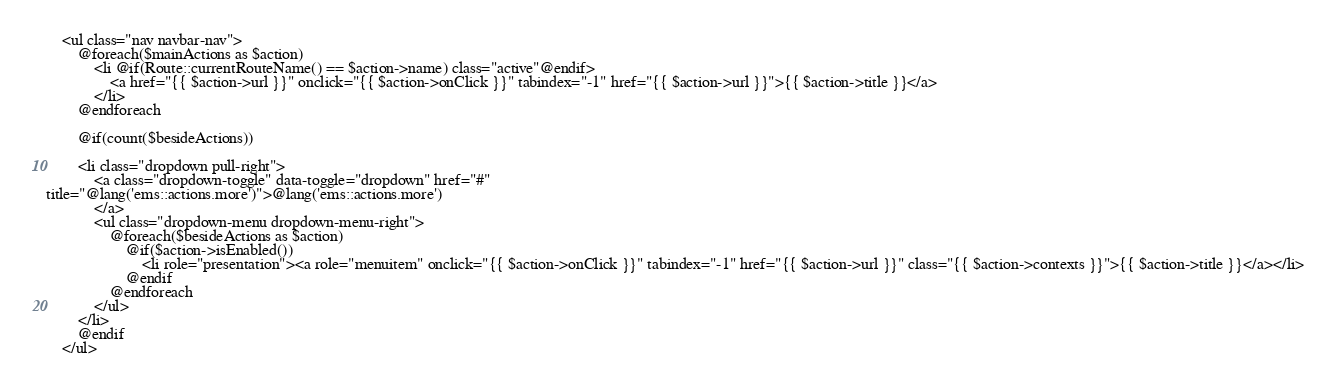Convert code to text. <code><loc_0><loc_0><loc_500><loc_500><_PHP_>    <ul class="nav navbar-nav">
        @foreach($mainActions as $action)
            <li @if(Route::currentRouteName() == $action->name) class="active"@endif>
                <a href="{{ $action->url }}" onclick="{{ $action->onClick }}" tabindex="-1" href="{{ $action->url }}">{{ $action->title }}</a>
            </li>
        @endforeach

        @if(count($besideActions))

        <li class="dropdown pull-right">
            <a class="dropdown-toggle" data-toggle="dropdown" href="#" 
title="@lang('ems::actions.more')">@lang('ems::actions.more')
            </a>
            <ul class="dropdown-menu dropdown-menu-right">
                @foreach($besideActions as $action)
                    @if($action->isEnabled())
                        <li role="presentation"><a role="menuitem" onclick="{{ $action->onClick }}" tabindex="-1" href="{{ $action->url }}" class="{{ $action->contexts }}">{{ $action->title }}</a></li>
                    @endif
                @endforeach
            </ul>
        </li>
        @endif
    </ul></code> 